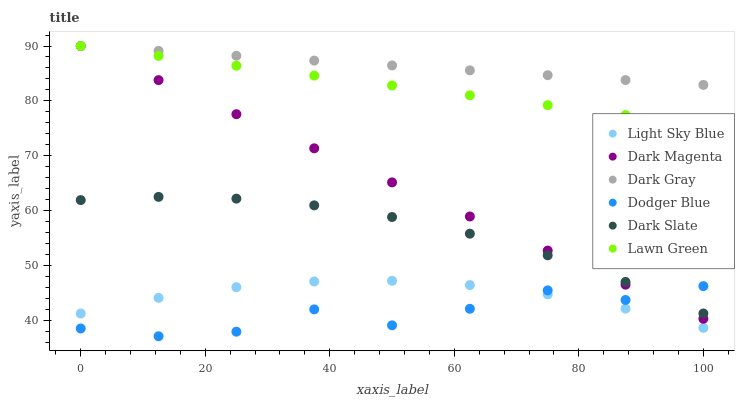Does Dodger Blue have the minimum area under the curve?
Answer yes or no. Yes. Does Dark Gray have the maximum area under the curve?
Answer yes or no. Yes. Does Dark Magenta have the minimum area under the curve?
Answer yes or no. No. Does Dark Magenta have the maximum area under the curve?
Answer yes or no. No. Is Lawn Green the smoothest?
Answer yes or no. Yes. Is Dodger Blue the roughest?
Answer yes or no. Yes. Is Dark Magenta the smoothest?
Answer yes or no. No. Is Dark Magenta the roughest?
Answer yes or no. No. Does Dodger Blue have the lowest value?
Answer yes or no. Yes. Does Dark Magenta have the lowest value?
Answer yes or no. No. Does Dark Gray have the highest value?
Answer yes or no. Yes. Does Dark Slate have the highest value?
Answer yes or no. No. Is Light Sky Blue less than Lawn Green?
Answer yes or no. Yes. Is Dark Gray greater than Dodger Blue?
Answer yes or no. Yes. Does Lawn Green intersect Dark Magenta?
Answer yes or no. Yes. Is Lawn Green less than Dark Magenta?
Answer yes or no. No. Is Lawn Green greater than Dark Magenta?
Answer yes or no. No. Does Light Sky Blue intersect Lawn Green?
Answer yes or no. No. 